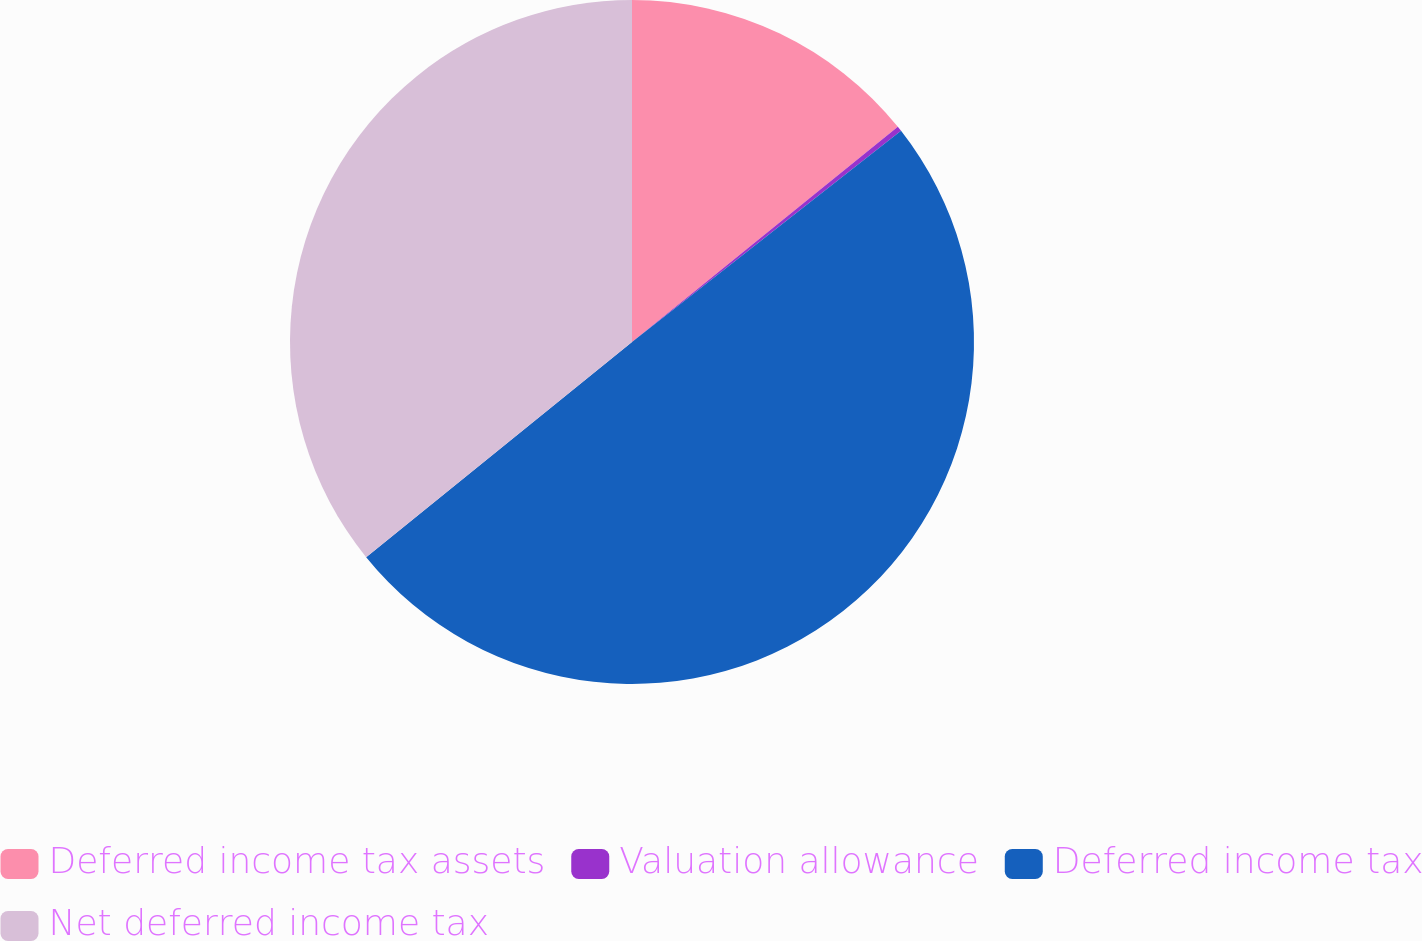<chart> <loc_0><loc_0><loc_500><loc_500><pie_chart><fcel>Deferred income tax assets<fcel>Valuation allowance<fcel>Deferred income tax<fcel>Net deferred income tax<nl><fcel>14.17%<fcel>0.24%<fcel>49.76%<fcel>35.83%<nl></chart> 